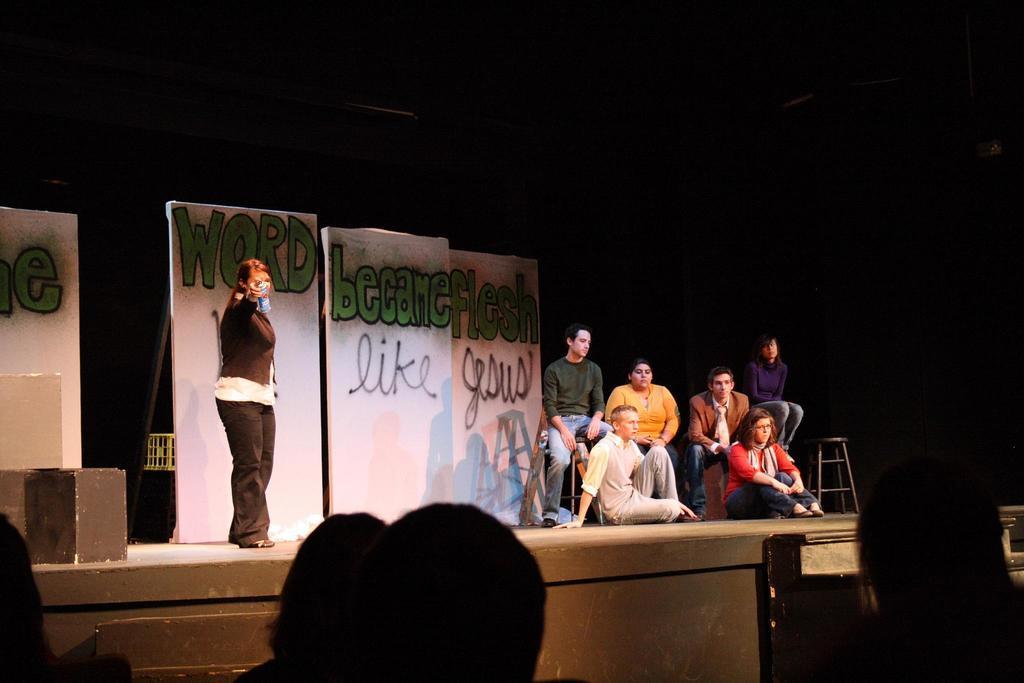Please provide a concise description of this image. In this image we can see a person holding an object and standing on the dais. There are people sitting. In the background there are boards. On the left there is a speaker and we can see a stool. 